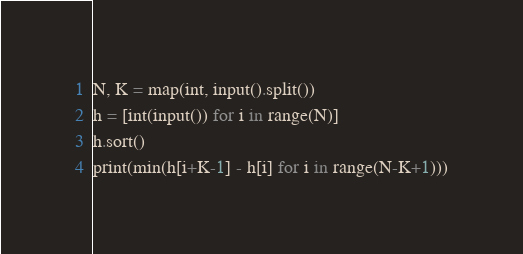<code> <loc_0><loc_0><loc_500><loc_500><_Python_>N, K = map(int, input().split())
h = [int(input()) for i in range(N)]
h.sort()
print(min(h[i+K-1] - h[i] for i in range(N-K+1)))</code> 